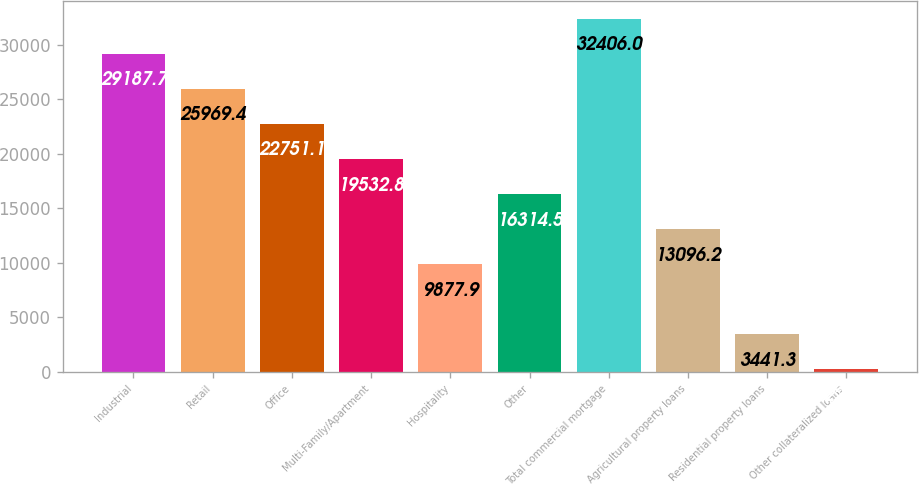Convert chart to OTSL. <chart><loc_0><loc_0><loc_500><loc_500><bar_chart><fcel>Industrial<fcel>Retail<fcel>Office<fcel>Multi-Family/Apartment<fcel>Hospitality<fcel>Other<fcel>Total commercial mortgage<fcel>Agricultural property loans<fcel>Residential property loans<fcel>Other collateralized loans<nl><fcel>29187.7<fcel>25969.4<fcel>22751.1<fcel>19532.8<fcel>9877.9<fcel>16314.5<fcel>32406<fcel>13096.2<fcel>3441.3<fcel>223<nl></chart> 